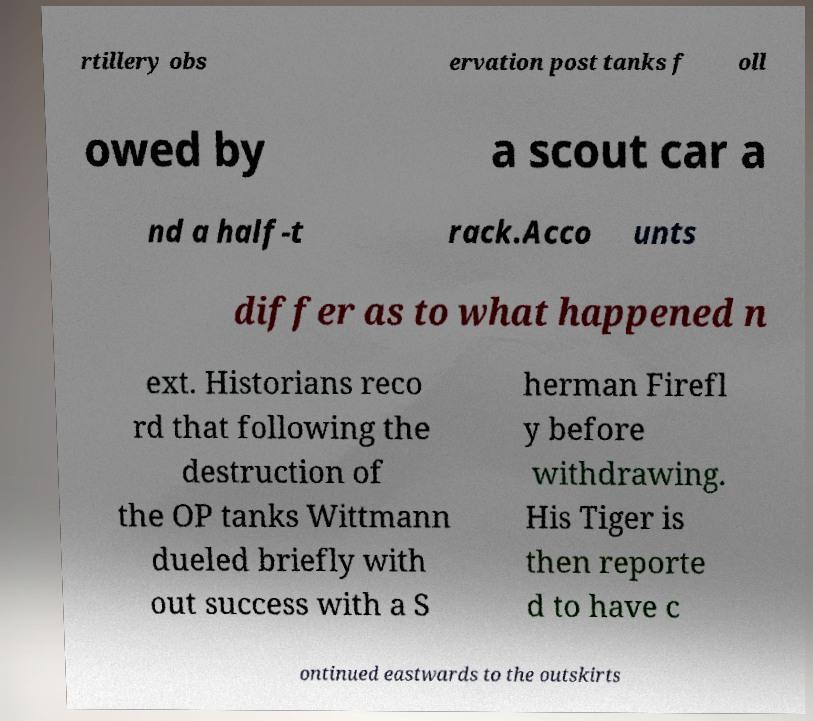There's text embedded in this image that I need extracted. Can you transcribe it verbatim? rtillery obs ervation post tanks f oll owed by a scout car a nd a half-t rack.Acco unts differ as to what happened n ext. Historians reco rd that following the destruction of the OP tanks Wittmann dueled briefly with out success with a S herman Firefl y before withdrawing. His Tiger is then reporte d to have c ontinued eastwards to the outskirts 